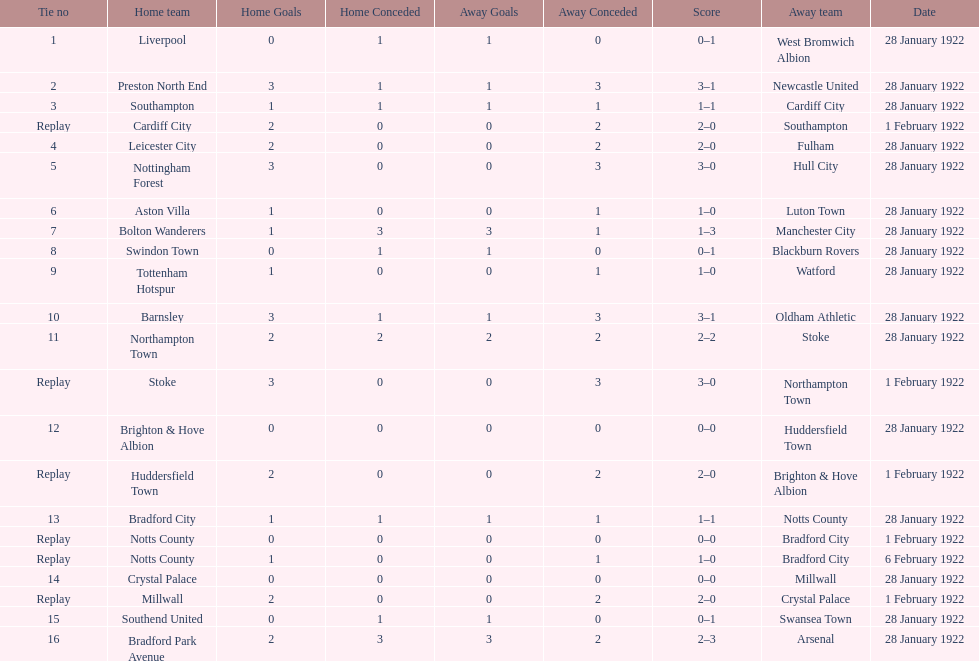Which game had a higher total number of goals scored, 1 or 16? 16. 